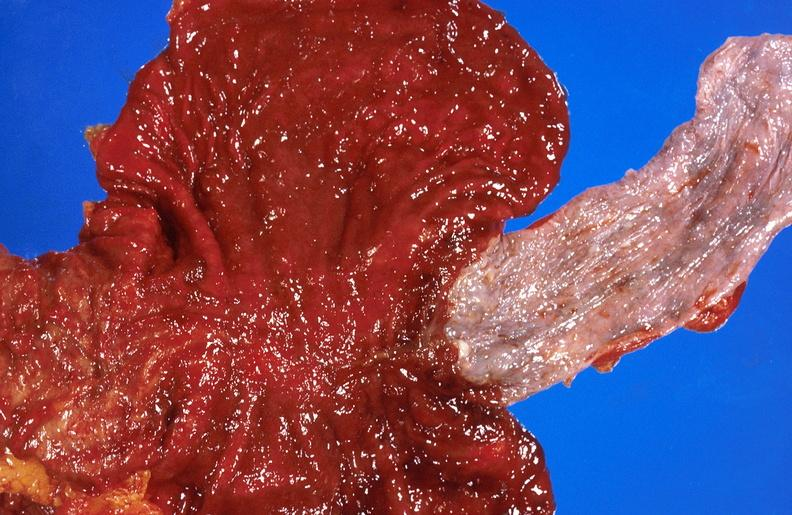what does this image show?
Answer the question using a single word or phrase. Alcoholic cirrhosis 